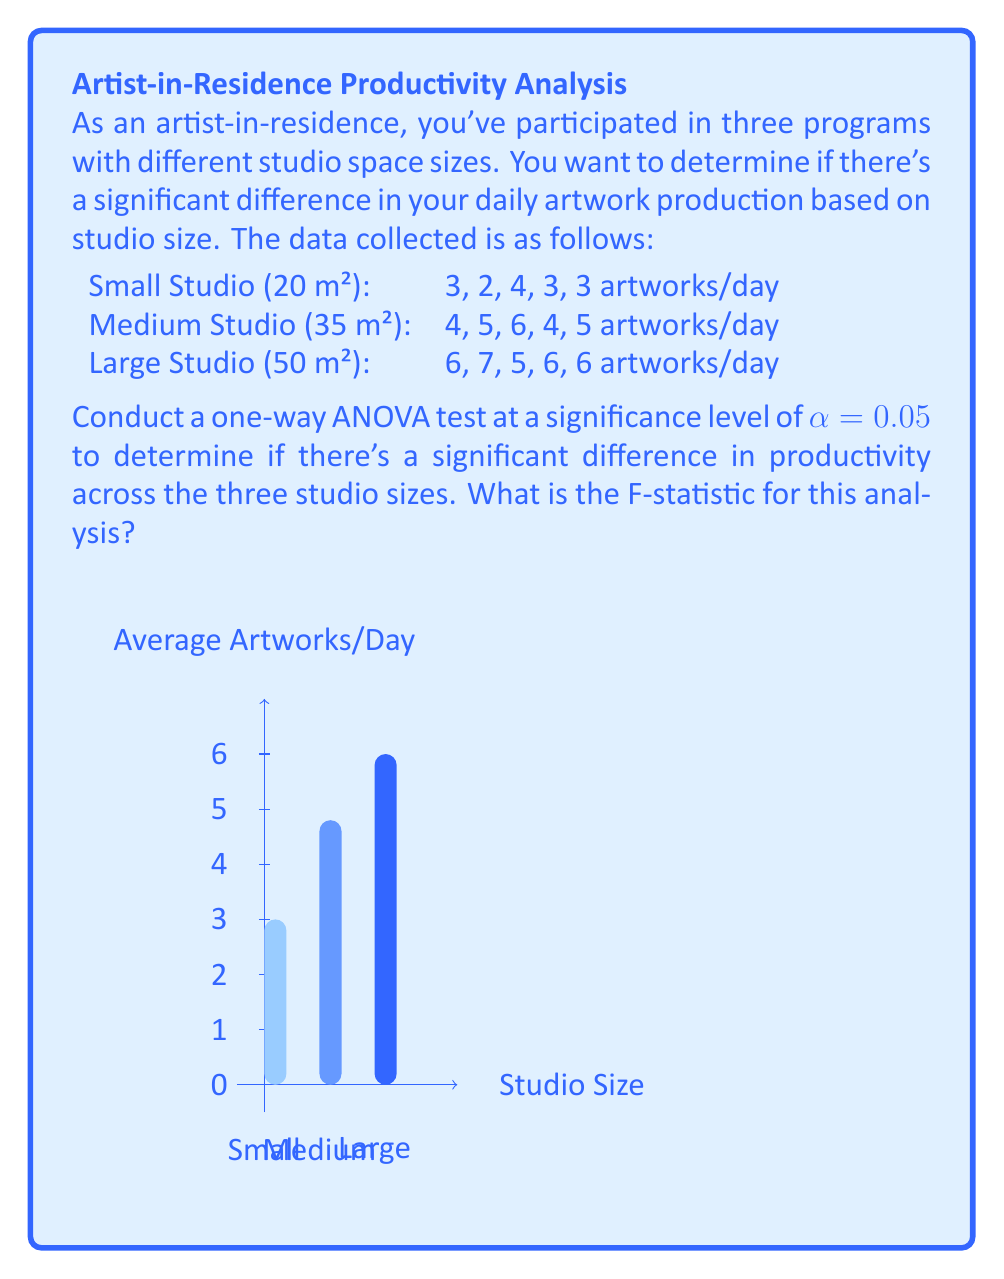Provide a solution to this math problem. To conduct a one-way ANOVA, we'll follow these steps:

1) Calculate the mean for each group:
   Small: $\bar{X}_1 = \frac{3+2+4+3+3}{5} = 3$
   Medium: $\bar{X}_2 = \frac{4+5+6+4+5}{5} = 4.8$
   Large: $\bar{X}_3 = \frac{6+7+5+6+6}{5} = 6$

2) Calculate the grand mean:
   $\bar{X} = \frac{3+4.8+6}{3} = 4.6$

3) Calculate SSB (Sum of Squares Between groups):
   $$SSB = \sum_{i=1}^{k} n_i(\bar{X}_i - \bar{X})^2$$
   $$SSB = 5(3-4.6)^2 + 5(4.8-4.6)^2 + 5(6-4.6)^2 = 28.6$$

4) Calculate SSW (Sum of Squares Within groups):
   $$SSW = \sum_{i=1}^{k} \sum_{j=1}^{n_i} (X_{ij} - \bar{X}_i)^2$$
   Small: $(3-3)^2 + (2-3)^2 + (4-3)^2 + (3-3)^2 + (3-3)^2 = 2$
   Medium: $(4-4.8)^2 + (5-4.8)^2 + (6-4.8)^2 + (4-4.8)^2 + (5-4.8)^2 = 2.8$
   Large: $(6-6)^2 + (7-6)^2 + (5-6)^2 + (6-6)^2 + (6-6)^2 = 2$
   $$SSW = 2 + 2.8 + 2 = 6.8$$

5) Calculate degrees of freedom:
   dfB (between) = k - 1 = 3 - 1 = 2
   dfW (within) = N - k = 15 - 3 = 12

6) Calculate Mean Square Between (MSB) and Mean Square Within (MSW):
   $$MSB = \frac{SSB}{dfB} = \frac{28.6}{2} = 14.3$$
   $$MSW = \frac{SSW}{dfW} = \frac{6.8}{12} = 0.567$$

7) Calculate the F-statistic:
   $$F = \frac{MSB}{MSW} = \frac{14.3}{0.567} = 25.22$$
Answer: F = 25.22 